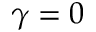<formula> <loc_0><loc_0><loc_500><loc_500>\gamma = 0</formula> 